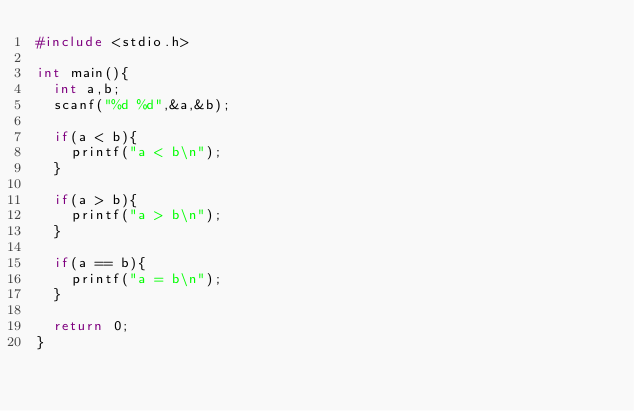<code> <loc_0><loc_0><loc_500><loc_500><_C_>#include <stdio.h>

int main(){
  int a,b;
  scanf("%d %d",&a,&b);

  if(a < b){
    printf("a < b\n");
  }

  if(a > b){
    printf("a > b\n");
  }

  if(a == b){
    printf("a = b\n");
  }

  return 0;
}</code> 